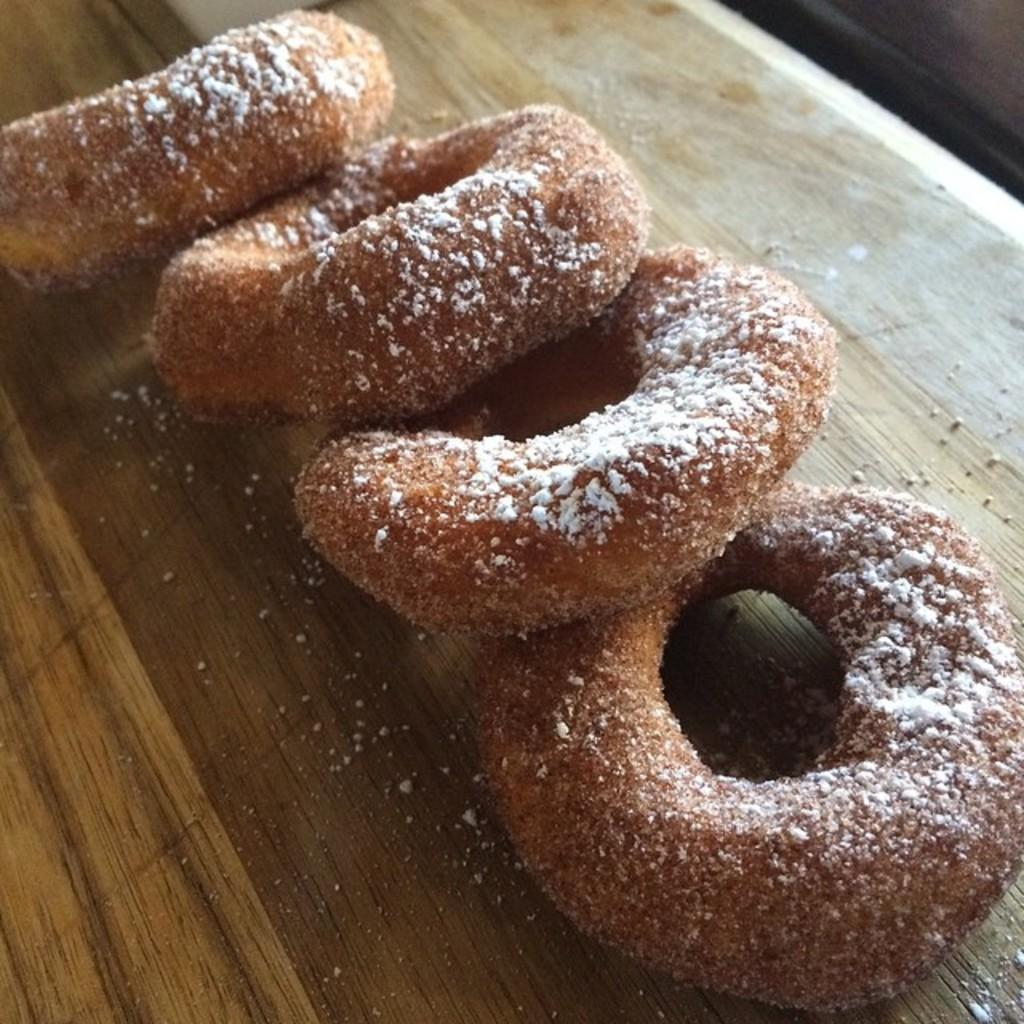What type of food can be seen in the image? There are donuts in the image. What substance is above the donuts in the image? There is flour above the donuts in the image. What material is the table made of in the image? The table in the image is made of wood. How does the quiet bait affect the position of the donuts in the image? There is no quiet bait present in the image, and therefore it cannot affect the position of the donuts. 